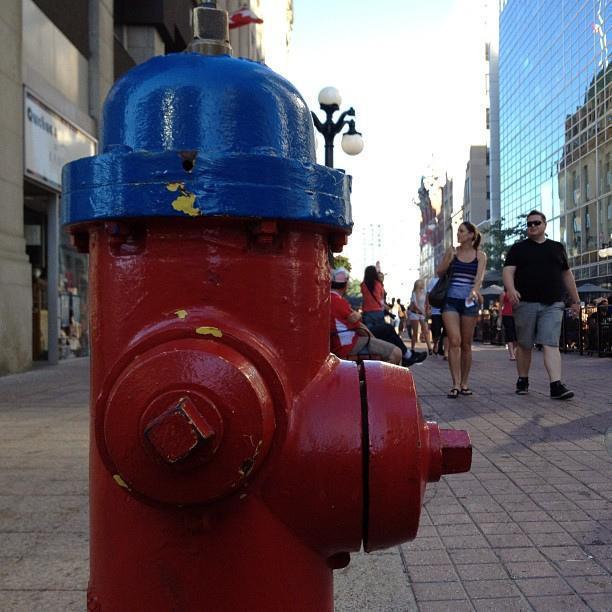What cannot be done in front of this object?
From the following four choices, select the correct answer to address the question.
Options: Singing, parking, eating, walking. Parking. 